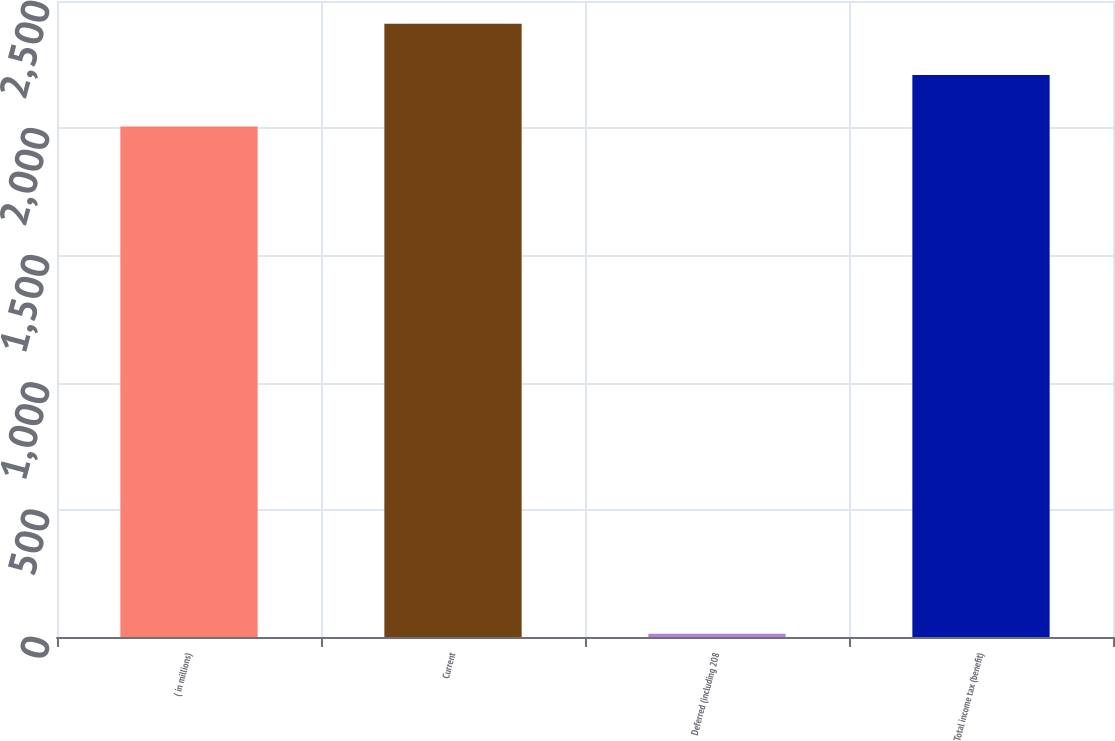<chart> <loc_0><loc_0><loc_500><loc_500><bar_chart><fcel>( in millions)<fcel>Current<fcel>Deferred (including 208<fcel>Total income tax (benefit)<nl><fcel>2007<fcel>2410.4<fcel>13<fcel>2208.7<nl></chart> 